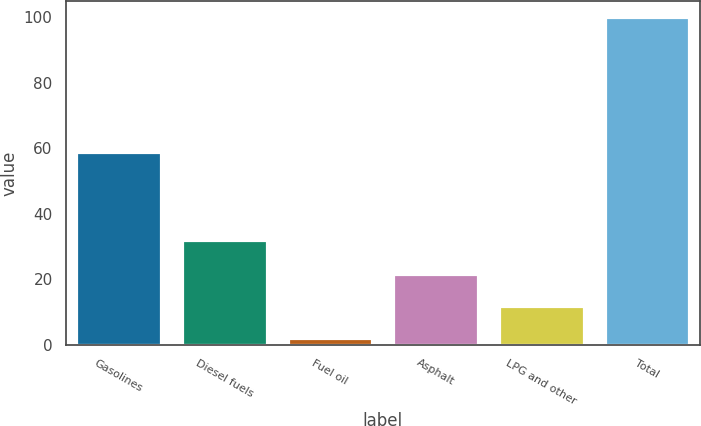Convert chart to OTSL. <chart><loc_0><loc_0><loc_500><loc_500><bar_chart><fcel>Gasolines<fcel>Diesel fuels<fcel>Fuel oil<fcel>Asphalt<fcel>LPG and other<fcel>Total<nl><fcel>59<fcel>32<fcel>2<fcel>21.6<fcel>11.8<fcel>100<nl></chart> 